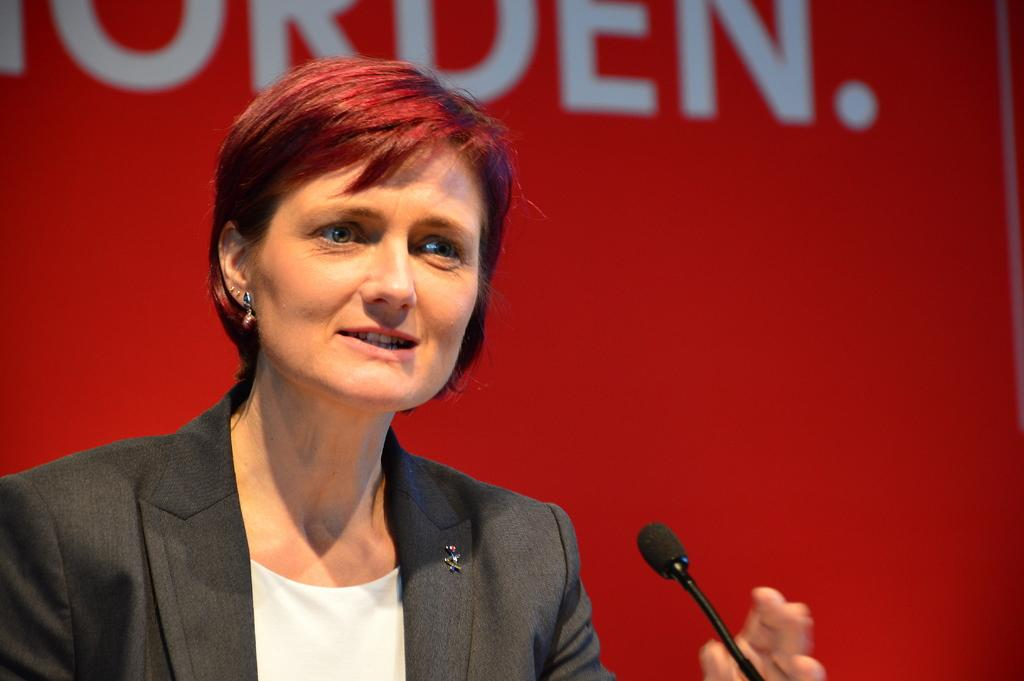Who or what is the main subject in the image? There is a person in the image. What object is the person holding or using? There is a microphone in the image. What color is the background of the image? The background of the image is red. What else can be seen in the background of the image besides the color? There is text visible in the background of the image. Can you tell me how many chances the person has to win a prize in the image? There is no indication of a prize or chances in the image; it only shows a person with a microphone and a red background with text. What type of rifle is visible in the image? There is no rifle present in the image. 